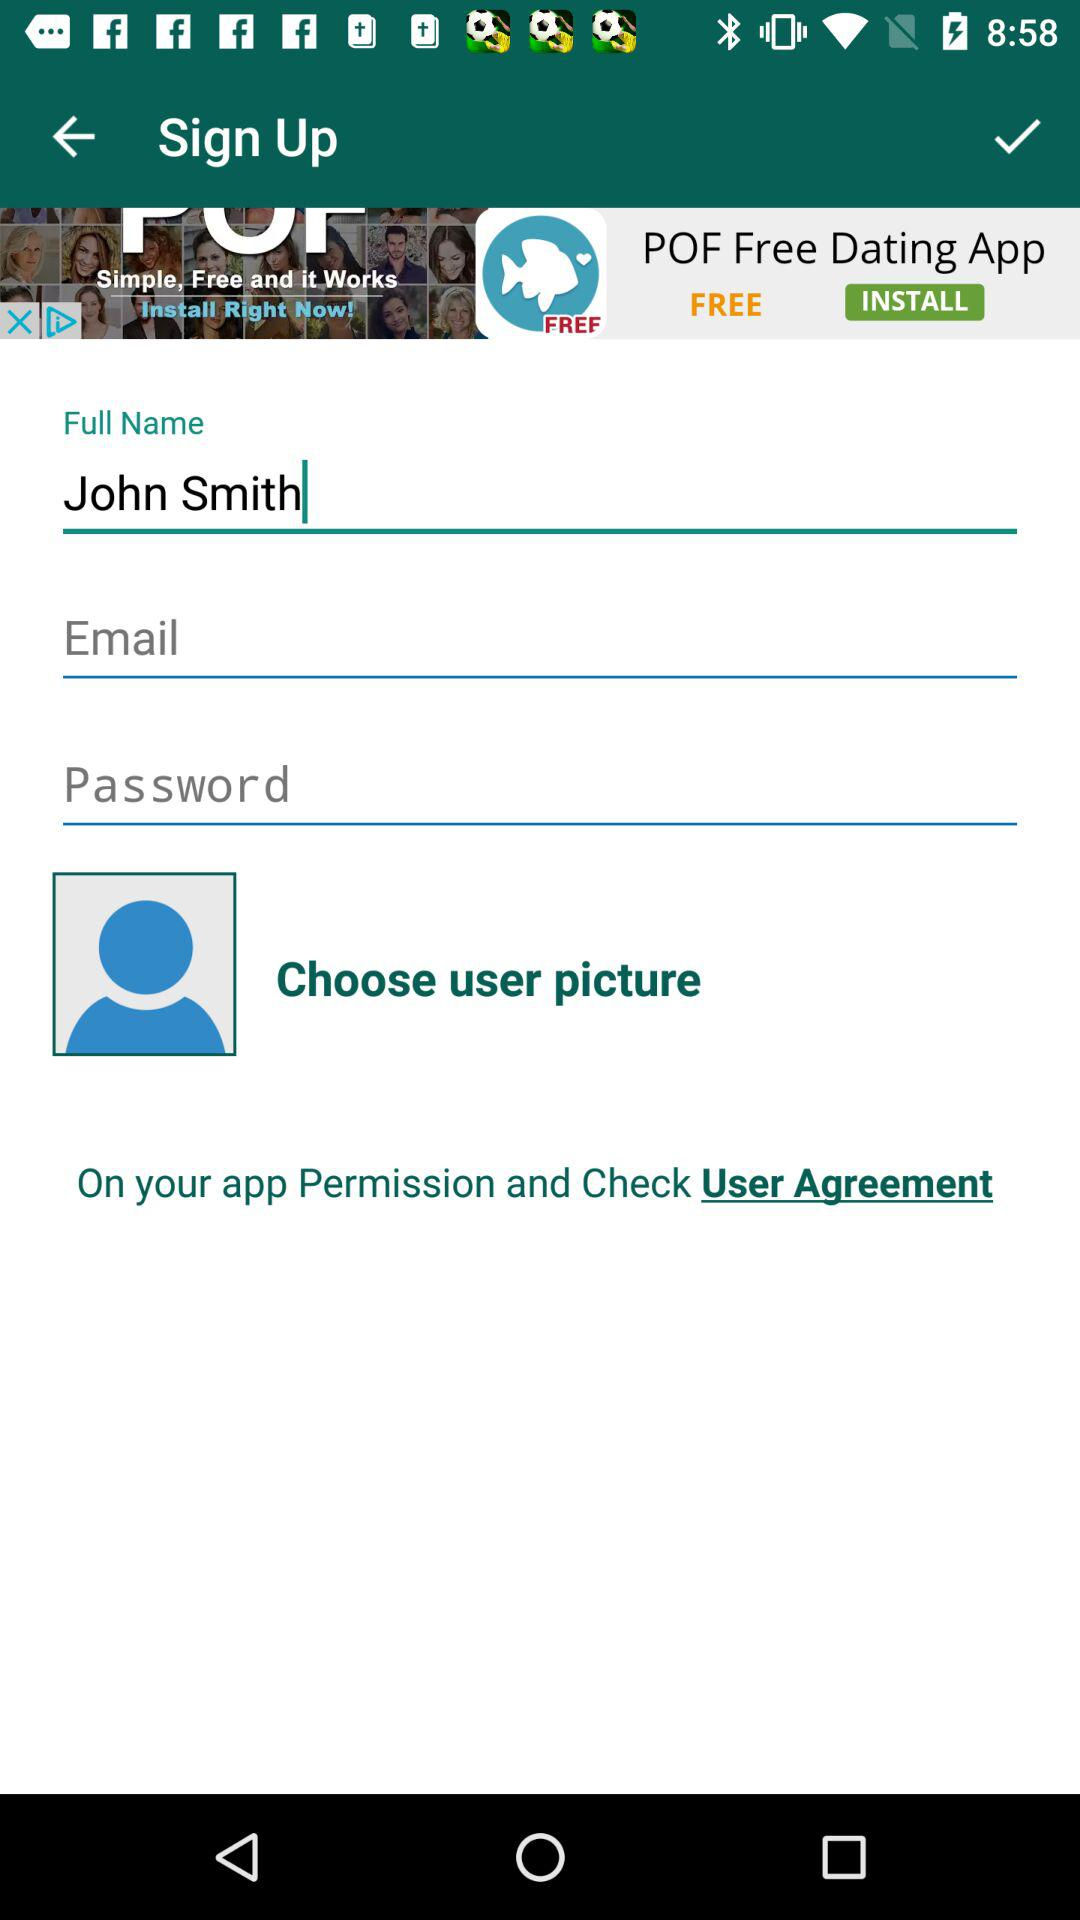What is the user name? The user name is John Smith. 